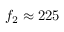Convert formula to latex. <formula><loc_0><loc_0><loc_500><loc_500>f _ { 2 } \approx 2 2 5</formula> 